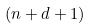Convert formula to latex. <formula><loc_0><loc_0><loc_500><loc_500>( n + d + 1 )</formula> 